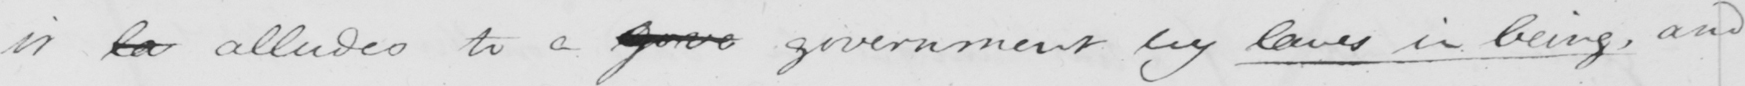What text is written in this handwritten line? it la alludes to a gorve government by laws in being , and 